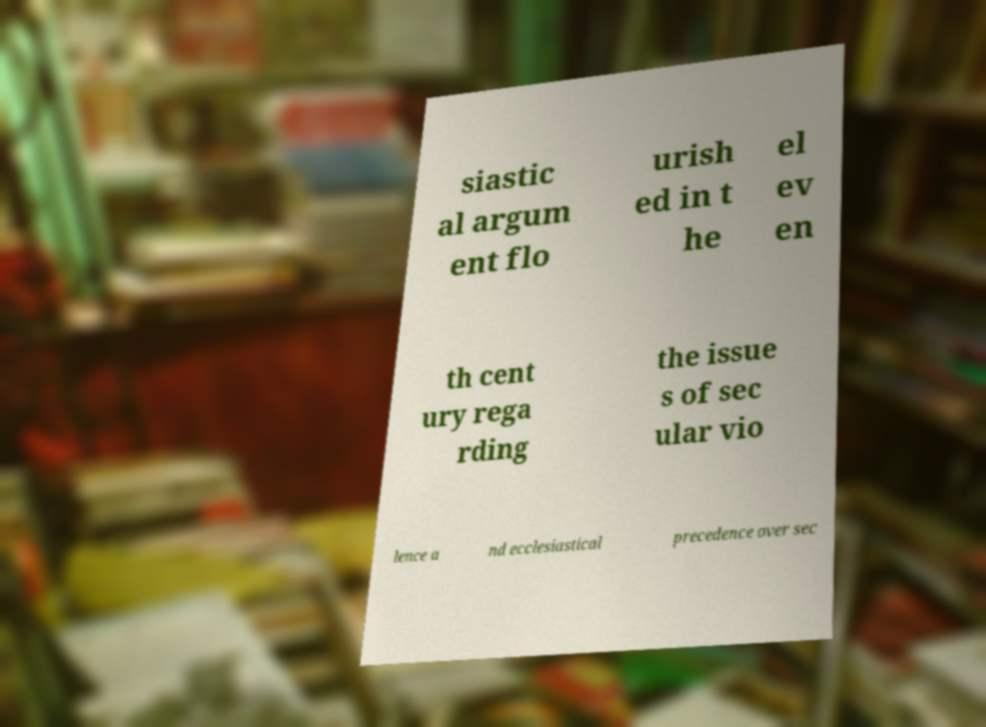Please read and relay the text visible in this image. What does it say? siastic al argum ent flo urish ed in t he el ev en th cent ury rega rding the issue s of sec ular vio lence a nd ecclesiastical precedence over sec 